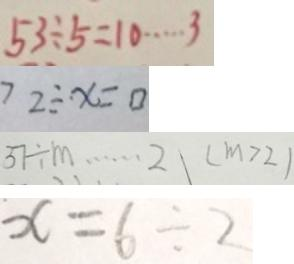Convert formula to latex. <formula><loc_0><loc_0><loc_500><loc_500>5 3 \div 5 = 1 0 \cdots 3 
 7 2 \div \cdot x = 0 
 3 7 \div m \cdots 2 ( m > 2 ) 
 x = 6 \div 2</formula> 